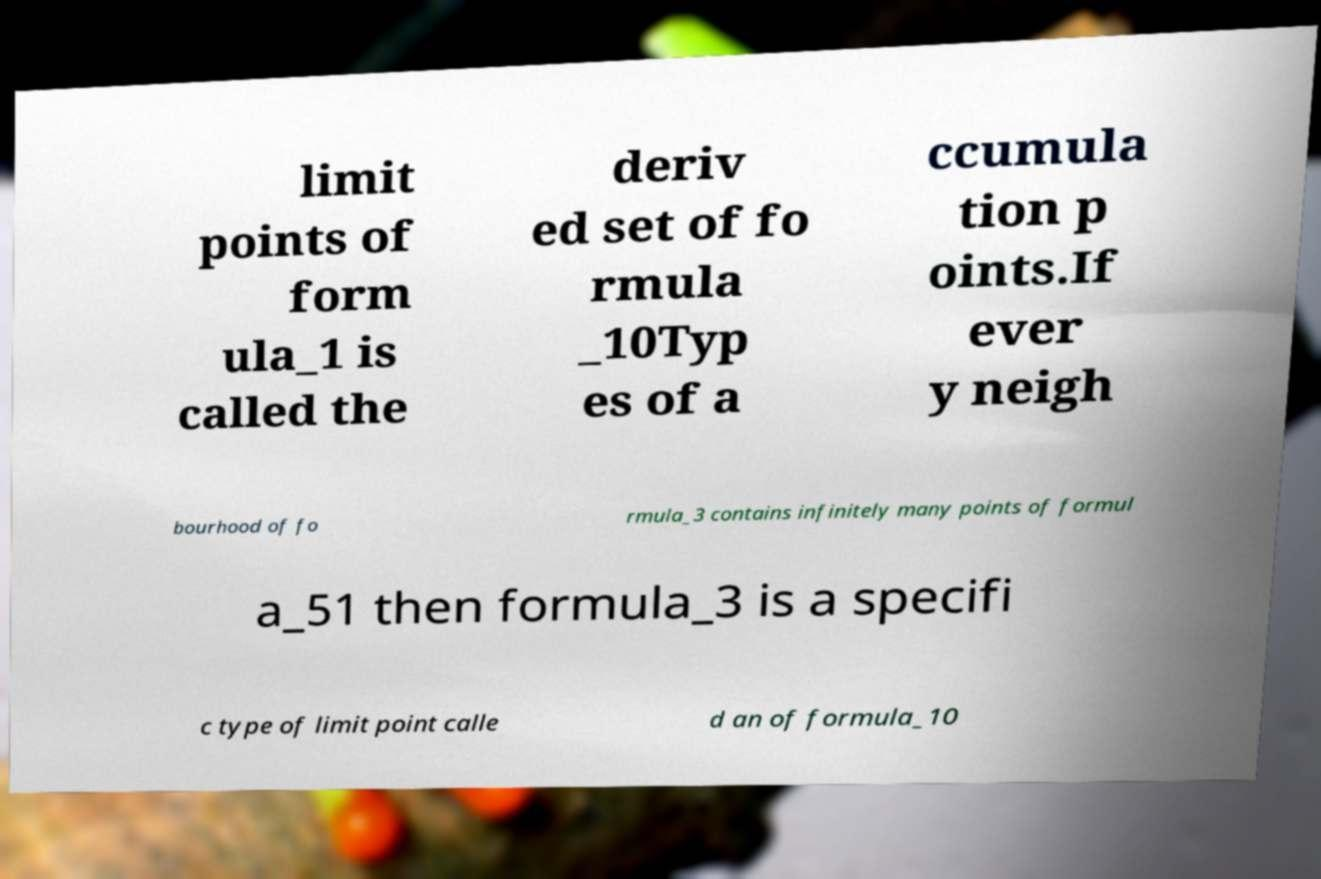For documentation purposes, I need the text within this image transcribed. Could you provide that? limit points of form ula_1 is called the deriv ed set of fo rmula _10Typ es of a ccumula tion p oints.If ever y neigh bourhood of fo rmula_3 contains infinitely many points of formul a_51 then formula_3 is a specifi c type of limit point calle d an of formula_10 